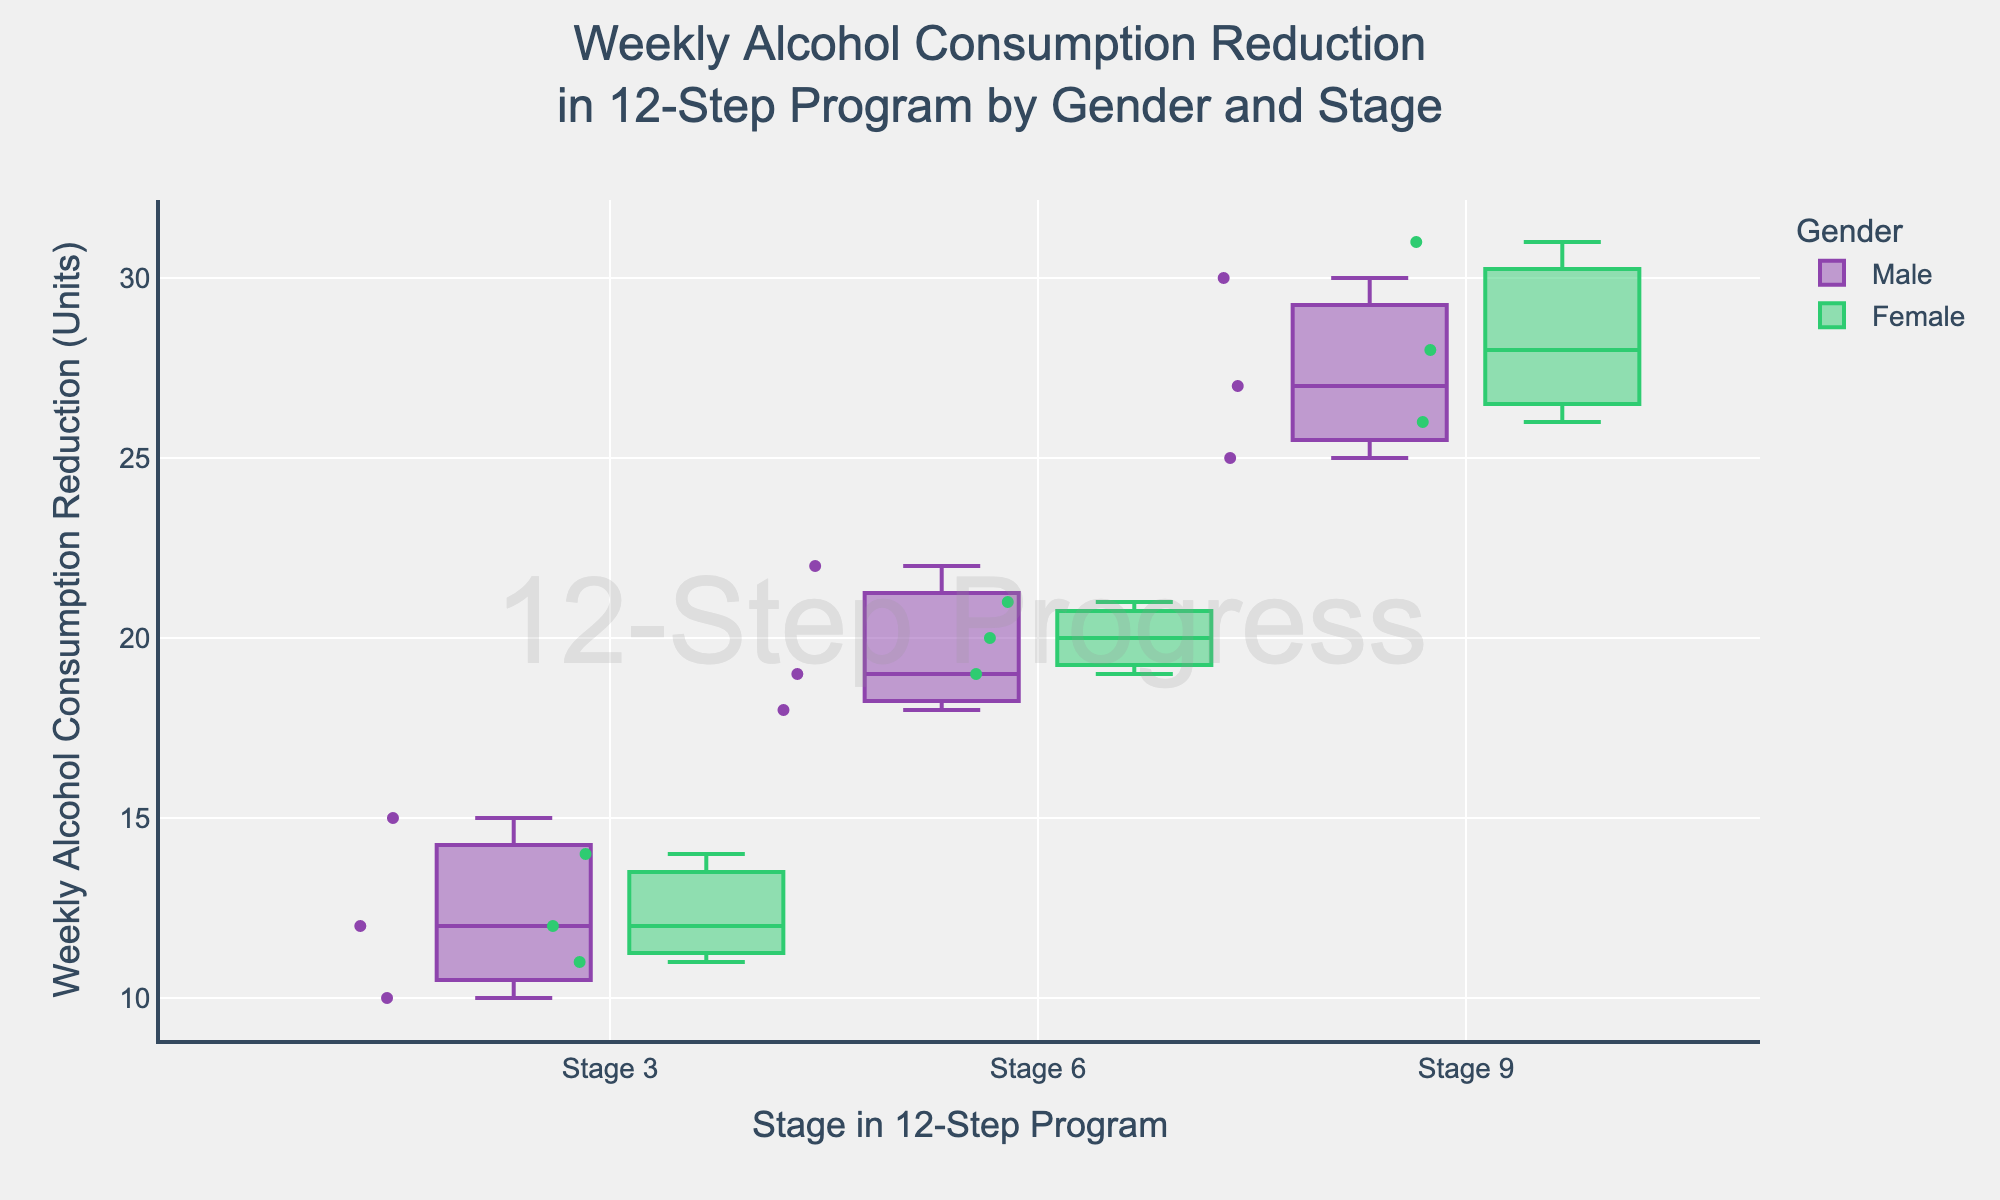How many stages are represented in the plot? The plot shows three distinct stages labeled on the x-axis.
Answer: Three What are the colors used to represent males and females in the plot? Males are represented in purple boxes, and females are in green boxes.
Answer: Purple for males, green for females Which stage shows the highest median weekly alcohol consumption reduction for females? By observing the plot, the stage with the highest median line within the green boxes for females is Stage 9.
Answer: Stage 9 Which gender has a wider range of weekly alcohol consumption reductions at Stage 6? Comparing the length of the boxes and whiskers for each gender at Stage 6, males have a wider range than females.
Answer: Males What's the difference in the median weekly alcohol consumption reduction between males and females at Stage 3? Find the median lines in each box for males and females at Stage 3 and subtract the female median from the male median.
Answer: 1 unit What trend can be observed in the weekly alcohol consumption reduction for both genders as they progress through the stages? Notice the median lines in the boxes increase from Stage 3 to Stage 9 for both genders, indicating a consistent reduction in alcohol consumption.
Answer: Increasing reduction Which stage has the least difference in weekly alcohol consumption reduction between males and females? Compare the proximity of the median lines of males and females across the stages; Stage 6 has the closest medians.
Answer: Stage 6 What is the interquartile range (IQR) for females at Stage 9? The IQR is the distance between the 25th percentile (bottom of the box) and the 75th percentile (top of the box) in the green box of Stage 9.
Answer: 5 units Which gender shows more variability in weekly alcohol consumption reduction at Stage 3? Variability can be inferred from the spread of the data points and the range of the whiskers. Males have more variability at Stage 3.
Answer: Males At which stage do both genders have the maximum possible weekly alcohol consumption reduction? Comparing the top whiskers and maximum points for both genders across all stages indicates Stage 9 has the highest values for both.
Answer: Stage 9 